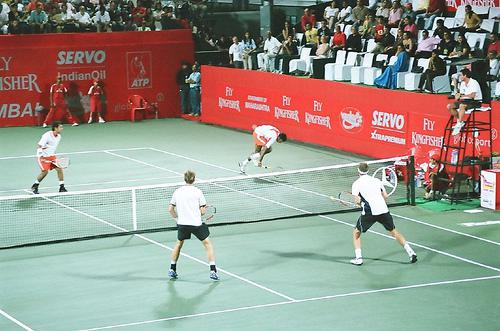Question: what game are they playing?
Choices:
A. Basketball.
B. Squash.
C. Tennis.
D. Football.
Answer with the letter. Answer: C Question: what color are the walls?
Choices:
A. Red.
B. White.
C. Tan.
D. Taupe.
Answer with the letter. Answer: A Question: where was this photo taken?
Choices:
A. Baseball diamond.
B. Tennis court.
C. Squash court.
D. Football field.
Answer with the letter. Answer: B 